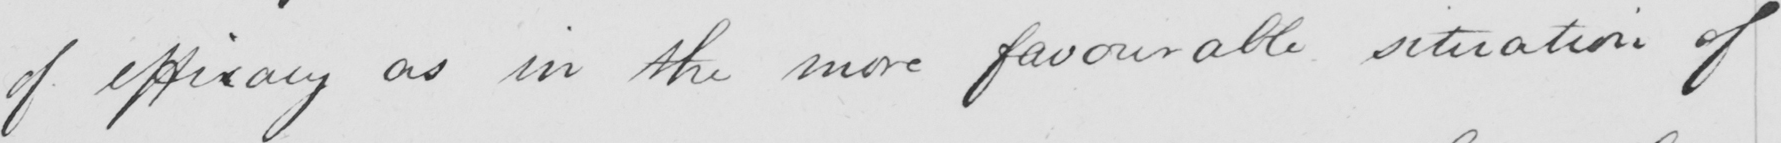Can you tell me what this handwritten text says? of efficacy as in the more favourable situation of 